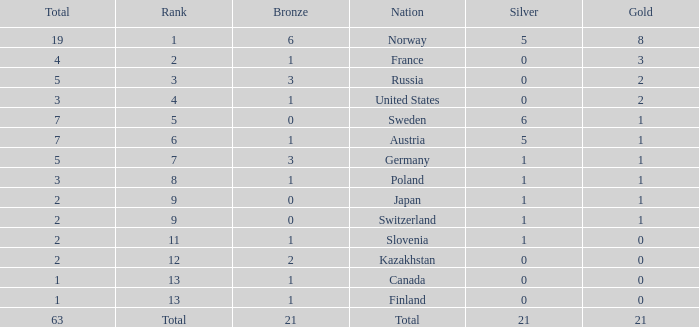What Rank has a gold smaller than 1, and a silver larger than 0? 11.0. 